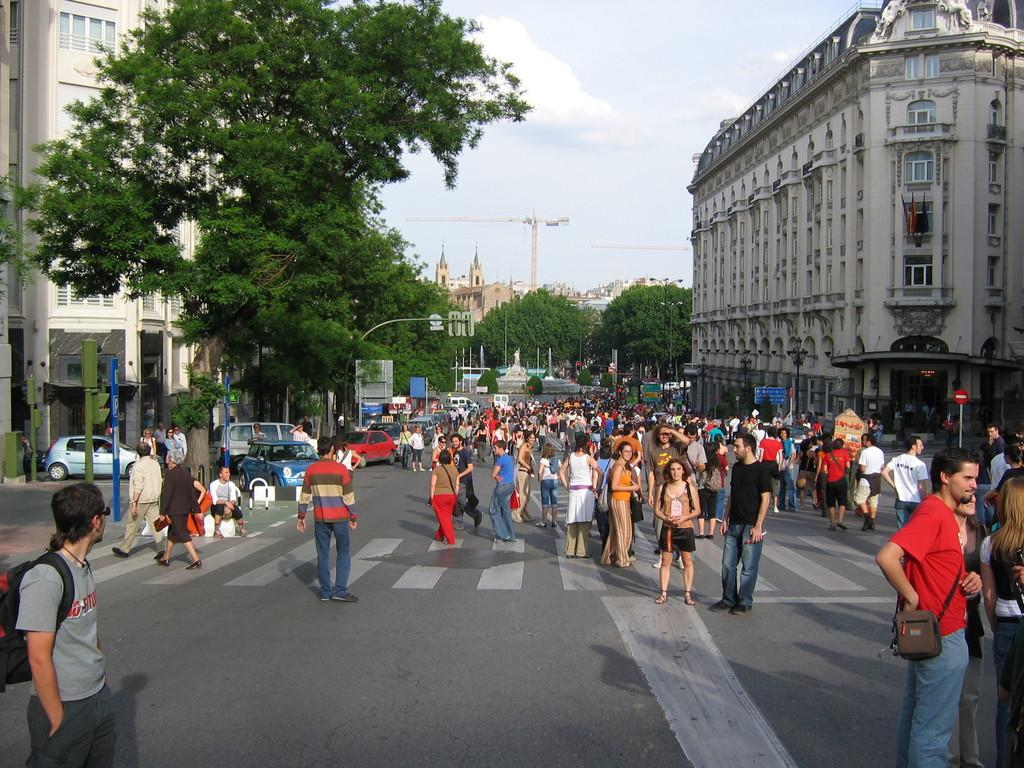What can be seen on the road in the image? There are people on the road in the image. What type of vegetation is present in the image? There are trees in the image. What structures can be seen in the image? There are buildings in the image. What are the poles used for in the image? The poles are likely used for supporting wires or signs in the image. What type of vehicles are present in the image? There are cars in the image. What is visible in the background of the image? The sky is visible in the background of the image, and clouds are present. What is the average income of the people in the image? There is no information about the income of the people in the image, as it is not relevant to the visual content. What type of scent can be detected in the image? There is no information about any scents in the image, as it is a visual medium. 